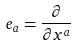<formula> <loc_0><loc_0><loc_500><loc_500>e _ { a } = \frac { \partial } { \partial x ^ { a } }</formula> 